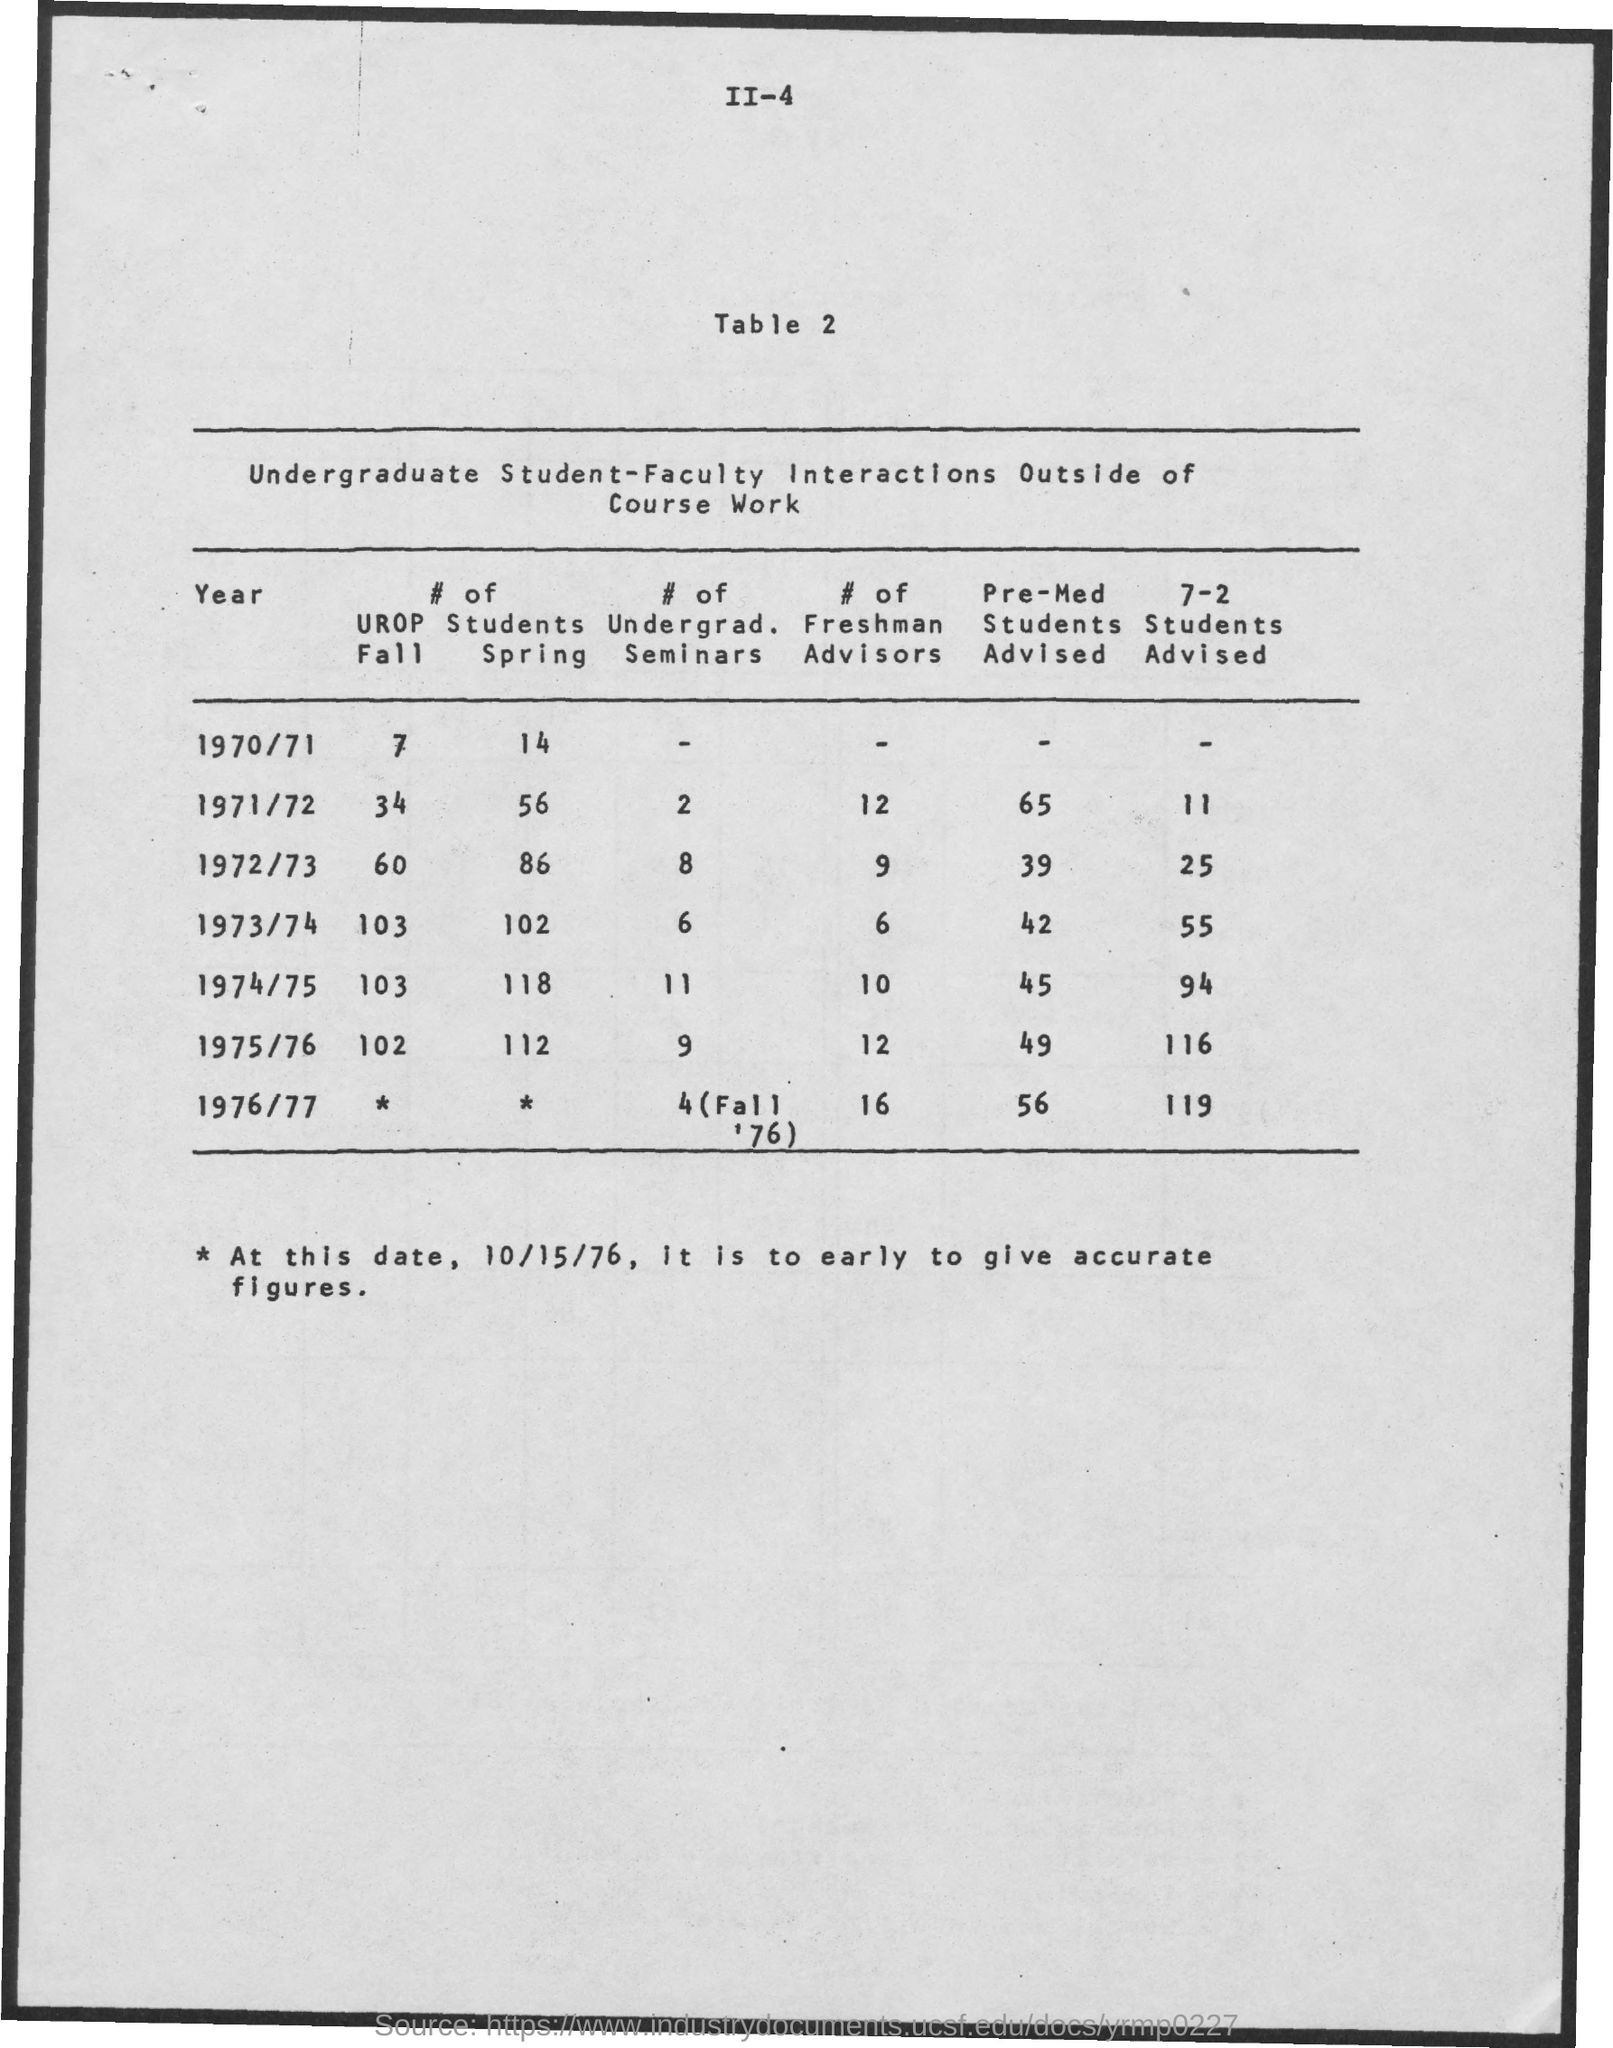What is the title of table 2?
Offer a terse response. Undergraduate Student-Faculty Interactions Outside of Course Work. Which year had the highest number of Students Spring?
Provide a succinct answer. 1974/75. 